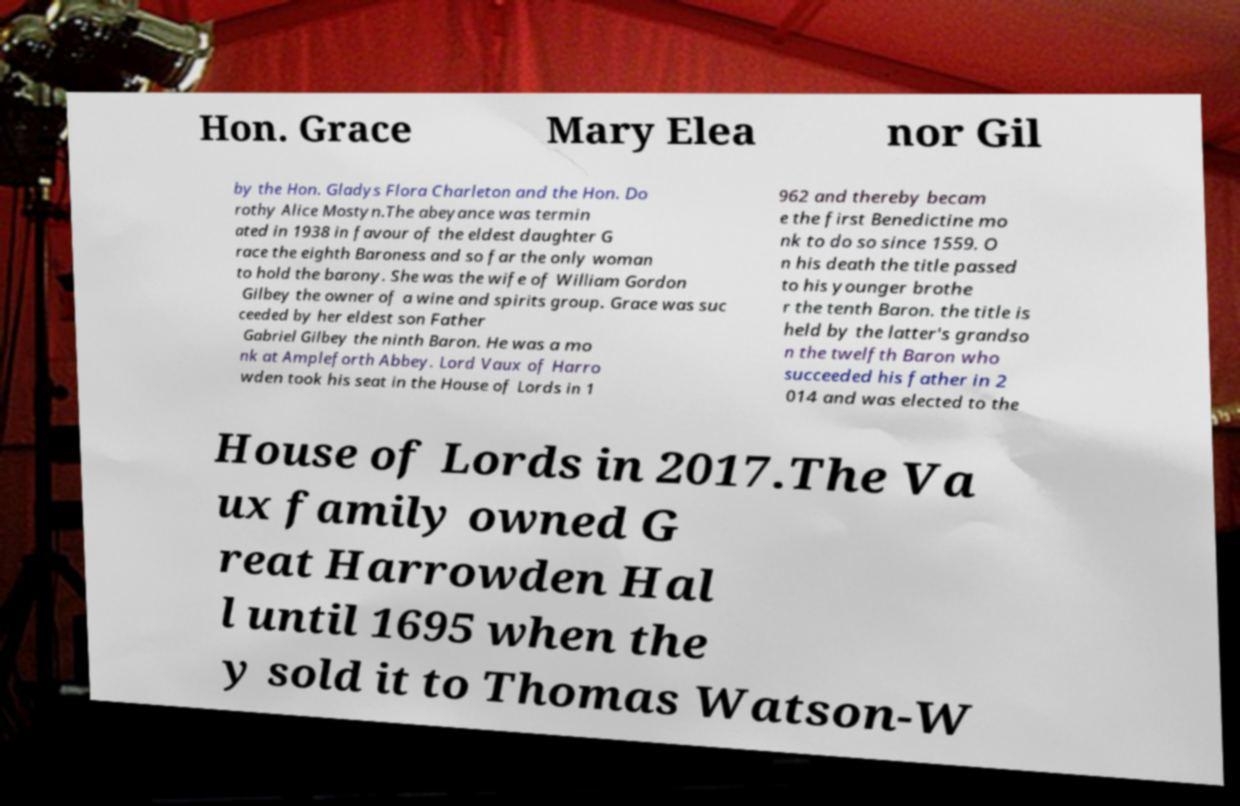Can you accurately transcribe the text from the provided image for me? Hon. Grace Mary Elea nor Gil by the Hon. Gladys Flora Charleton and the Hon. Do rothy Alice Mostyn.The abeyance was termin ated in 1938 in favour of the eldest daughter G race the eighth Baroness and so far the only woman to hold the barony. She was the wife of William Gordon Gilbey the owner of a wine and spirits group. Grace was suc ceeded by her eldest son Father Gabriel Gilbey the ninth Baron. He was a mo nk at Ampleforth Abbey. Lord Vaux of Harro wden took his seat in the House of Lords in 1 962 and thereby becam e the first Benedictine mo nk to do so since 1559. O n his death the title passed to his younger brothe r the tenth Baron. the title is held by the latter's grandso n the twelfth Baron who succeeded his father in 2 014 and was elected to the House of Lords in 2017.The Va ux family owned G reat Harrowden Hal l until 1695 when the y sold it to Thomas Watson-W 